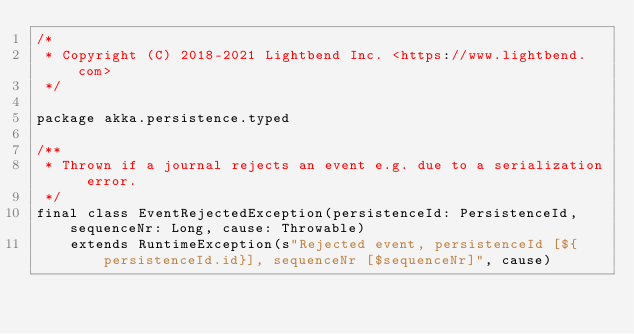<code> <loc_0><loc_0><loc_500><loc_500><_Scala_>/*
 * Copyright (C) 2018-2021 Lightbend Inc. <https://www.lightbend.com>
 */

package akka.persistence.typed

/**
 * Thrown if a journal rejects an event e.g. due to a serialization error.
 */
final class EventRejectedException(persistenceId: PersistenceId, sequenceNr: Long, cause: Throwable)
    extends RuntimeException(s"Rejected event, persistenceId [${persistenceId.id}], sequenceNr [$sequenceNr]", cause)
</code> 